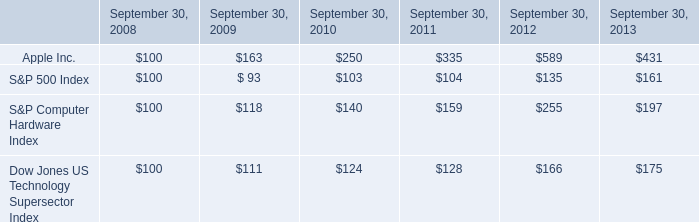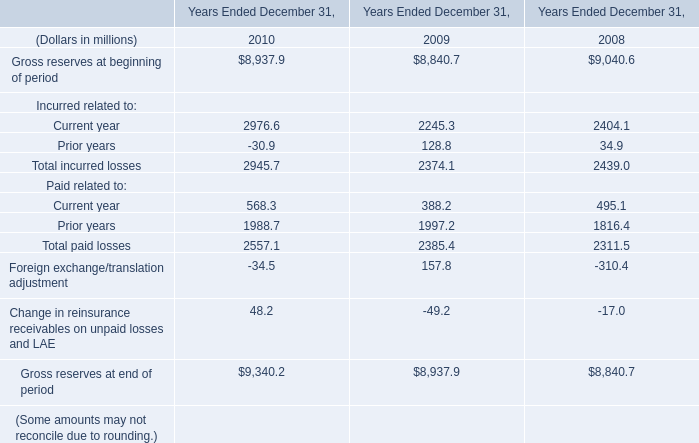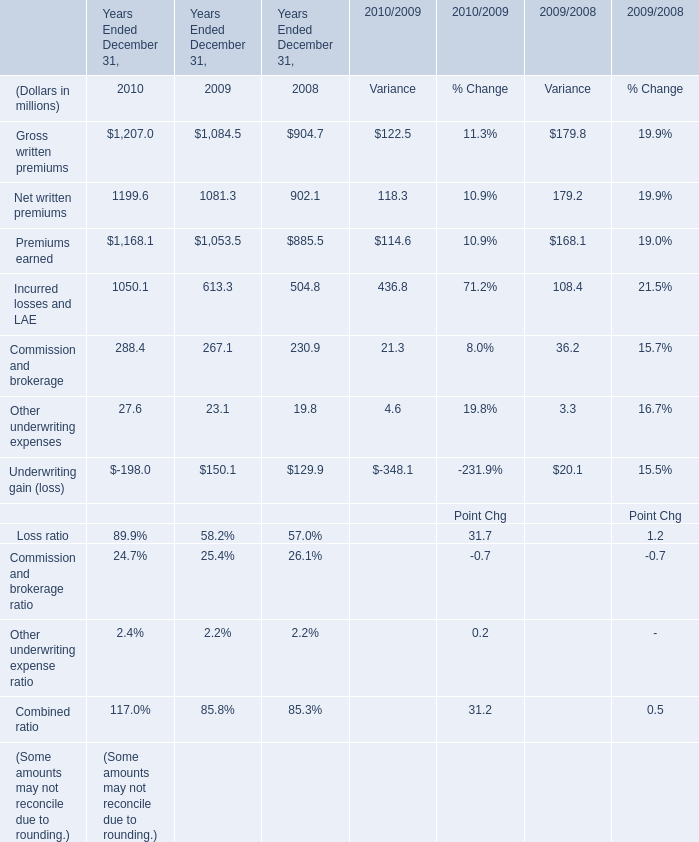What's the average of the Other underwriting expenses in the years where Gross reserves at beginning of period is positive? (in million) 
Computations: (((27.6 + 23.1) + 19.8) / 3)
Answer: 23.5. What is the sum of Gross written premiums, Net written premiums and Premiums earned in 2010 ? (in million) 
Computations: ((1207 + 1199.6) + 1168.1)
Answer: 3574.7. 